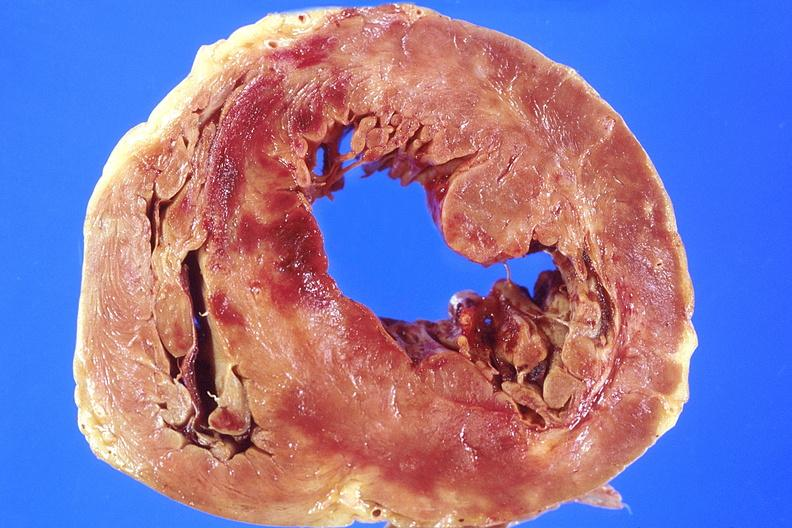where is this?
Answer the question using a single word or phrase. Heart 